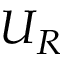Convert formula to latex. <formula><loc_0><loc_0><loc_500><loc_500>U _ { R }</formula> 